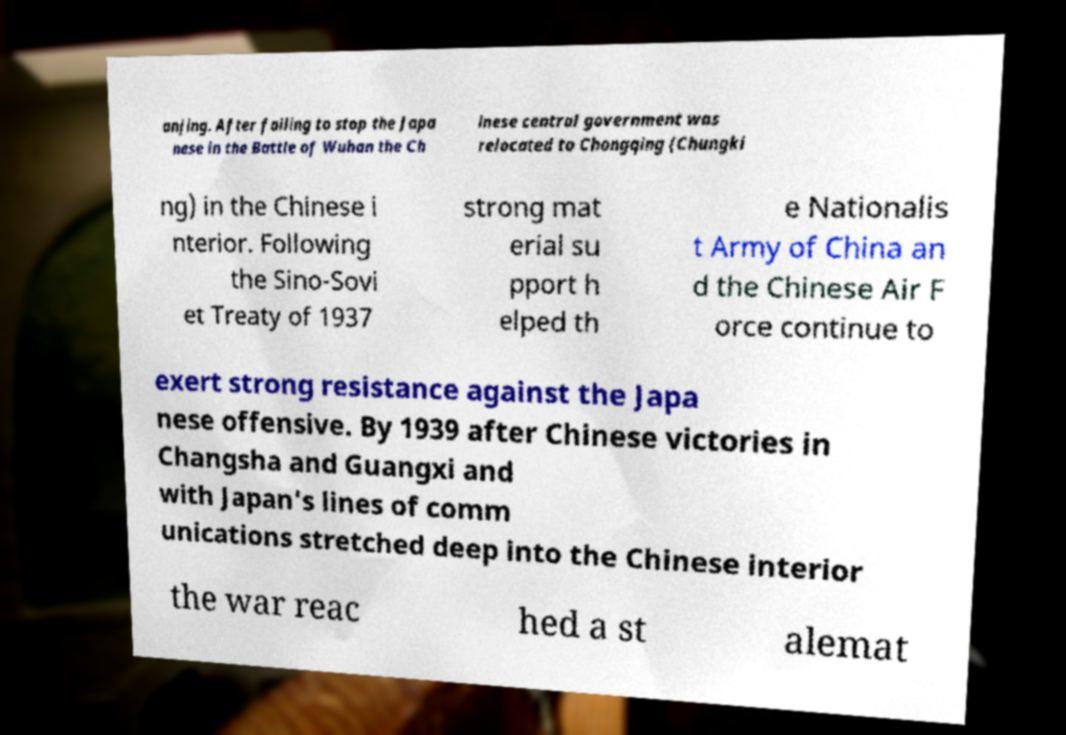For documentation purposes, I need the text within this image transcribed. Could you provide that? anjing. After failing to stop the Japa nese in the Battle of Wuhan the Ch inese central government was relocated to Chongqing (Chungki ng) in the Chinese i nterior. Following the Sino-Sovi et Treaty of 1937 strong mat erial su pport h elped th e Nationalis t Army of China an d the Chinese Air F orce continue to exert strong resistance against the Japa nese offensive. By 1939 after Chinese victories in Changsha and Guangxi and with Japan's lines of comm unications stretched deep into the Chinese interior the war reac hed a st alemat 